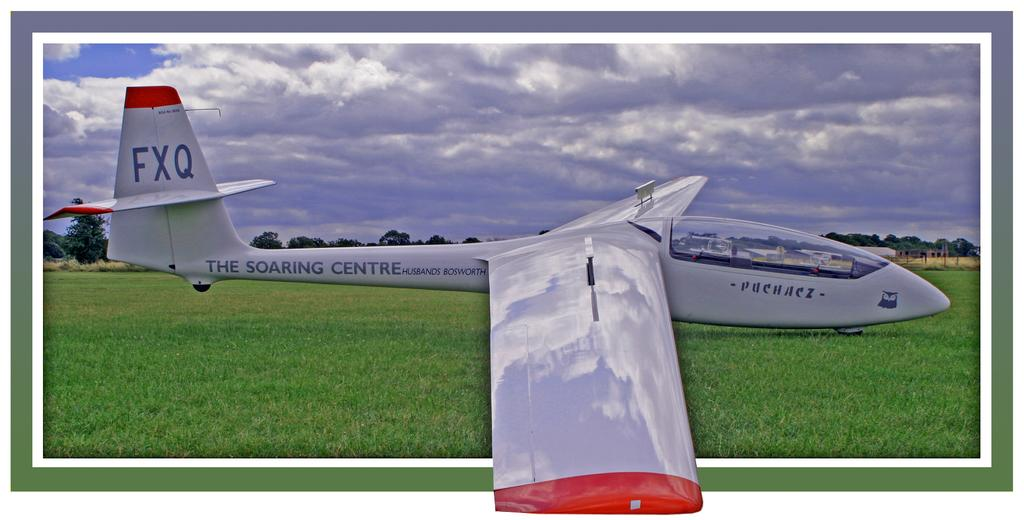<image>
Render a clear and concise summary of the photo. the soaring centre plane appears to be strangely shaped 